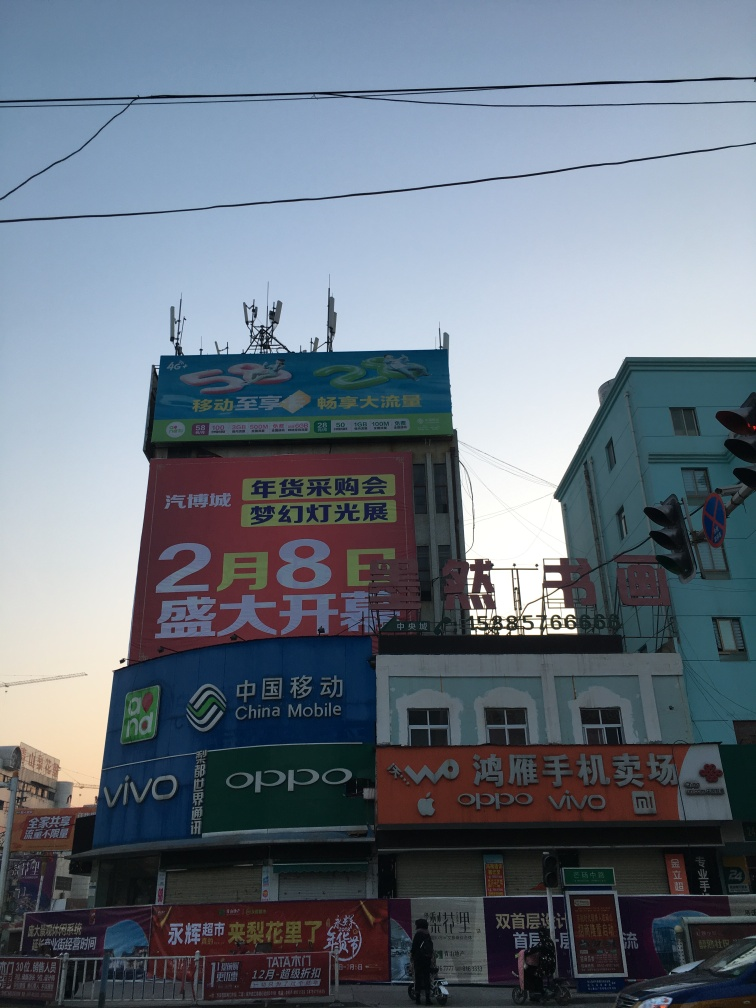What kind of businesses are advertised on this building? The building features advertisements for various tech companies, particularly mobile phone brands such as OPPO, vivo, and Xiaomi. There are also mentions of China Mobile, suggesting services related to telecom. 